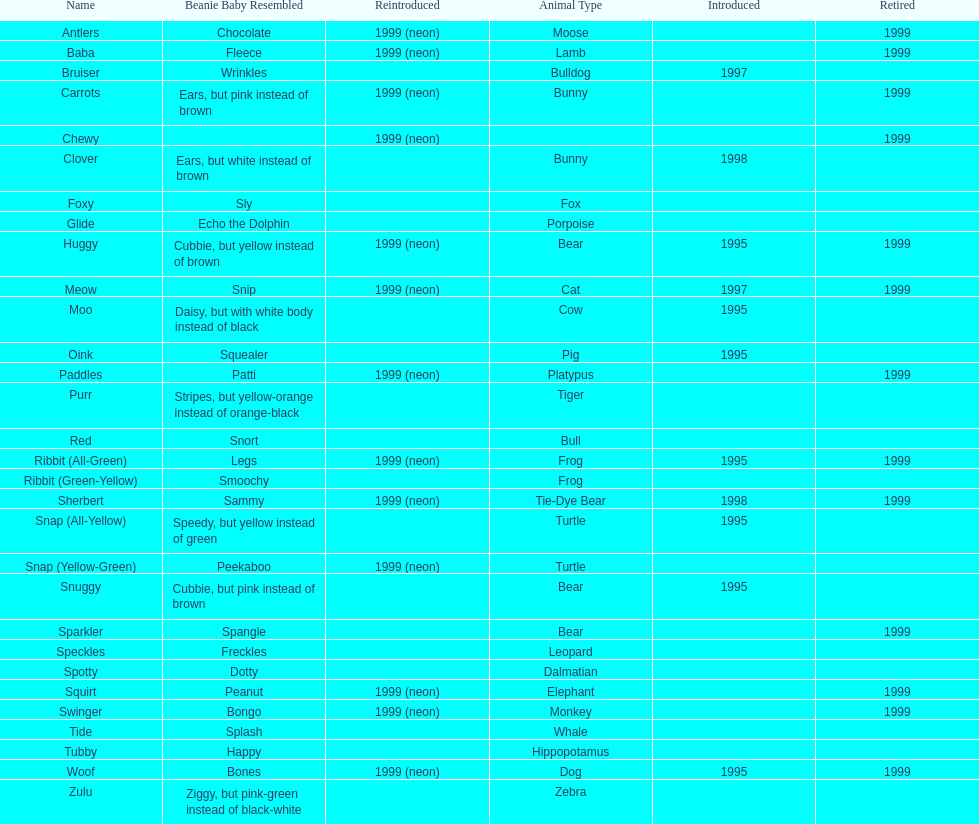In what year were the first pillow pals introduced? 1995. 